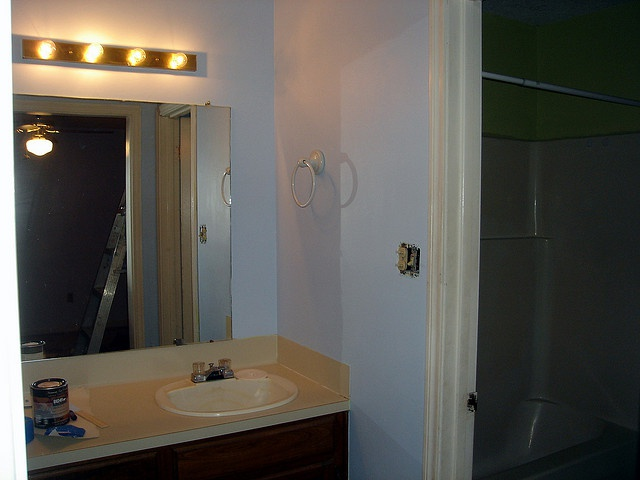Describe the objects in this image and their specific colors. I can see a sink in white and gray tones in this image. 